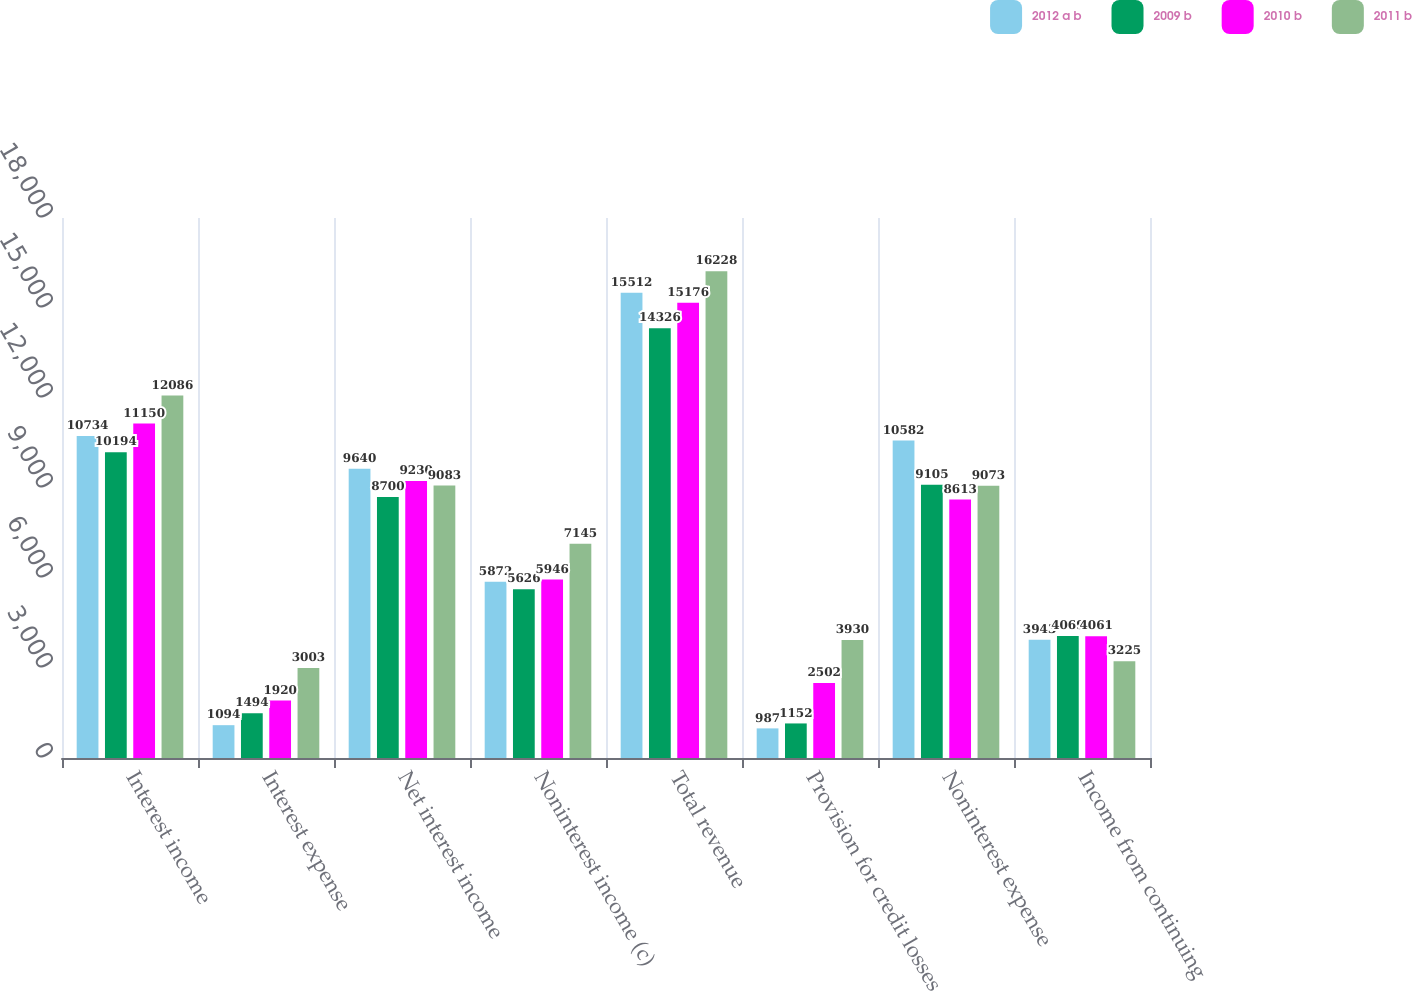Convert chart to OTSL. <chart><loc_0><loc_0><loc_500><loc_500><stacked_bar_chart><ecel><fcel>Interest income<fcel>Interest expense<fcel>Net interest income<fcel>Noninterest income (c)<fcel>Total revenue<fcel>Provision for credit losses<fcel>Noninterest expense<fcel>Income from continuing<nl><fcel>2012 a b<fcel>10734<fcel>1094<fcel>9640<fcel>5872<fcel>15512<fcel>987<fcel>10582<fcel>3943<nl><fcel>2009 b<fcel>10194<fcel>1494<fcel>8700<fcel>5626<fcel>14326<fcel>1152<fcel>9105<fcel>4069<nl><fcel>2010 b<fcel>11150<fcel>1920<fcel>9230<fcel>5946<fcel>15176<fcel>2502<fcel>8613<fcel>4061<nl><fcel>2011 b<fcel>12086<fcel>3003<fcel>9083<fcel>7145<fcel>16228<fcel>3930<fcel>9073<fcel>3225<nl></chart> 